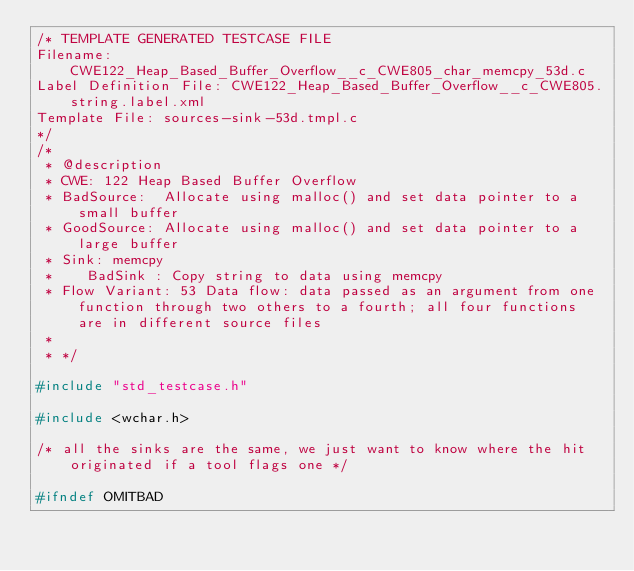Convert code to text. <code><loc_0><loc_0><loc_500><loc_500><_C_>/* TEMPLATE GENERATED TESTCASE FILE
Filename: CWE122_Heap_Based_Buffer_Overflow__c_CWE805_char_memcpy_53d.c
Label Definition File: CWE122_Heap_Based_Buffer_Overflow__c_CWE805.string.label.xml
Template File: sources-sink-53d.tmpl.c
*/
/*
 * @description
 * CWE: 122 Heap Based Buffer Overflow
 * BadSource:  Allocate using malloc() and set data pointer to a small buffer
 * GoodSource: Allocate using malloc() and set data pointer to a large buffer
 * Sink: memcpy
 *    BadSink : Copy string to data using memcpy
 * Flow Variant: 53 Data flow: data passed as an argument from one function through two others to a fourth; all four functions are in different source files
 *
 * */

#include "std_testcase.h"

#include <wchar.h>

/* all the sinks are the same, we just want to know where the hit originated if a tool flags one */

#ifndef OMITBAD
</code> 